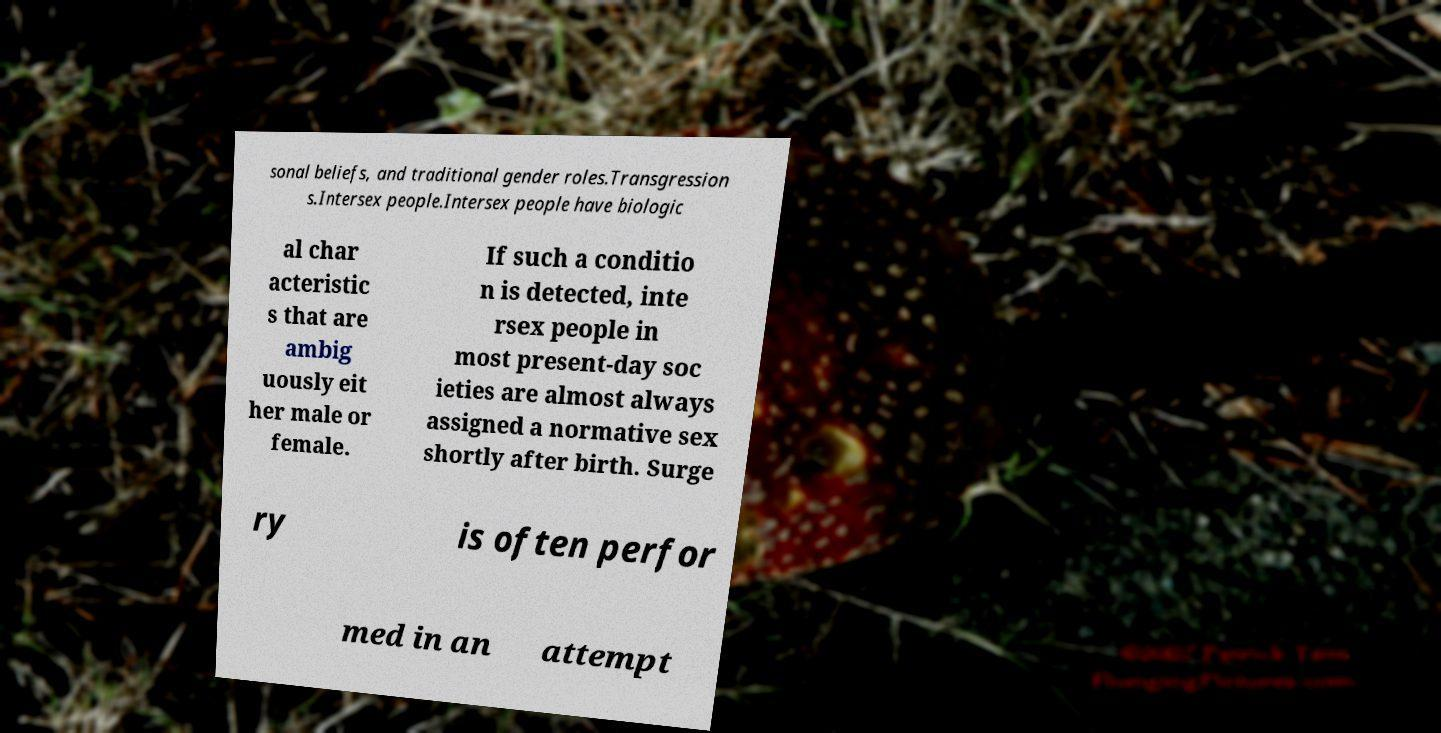For documentation purposes, I need the text within this image transcribed. Could you provide that? sonal beliefs, and traditional gender roles.Transgression s.Intersex people.Intersex people have biologic al char acteristic s that are ambig uously eit her male or female. If such a conditio n is detected, inte rsex people in most present-day soc ieties are almost always assigned a normative sex shortly after birth. Surge ry is often perfor med in an attempt 